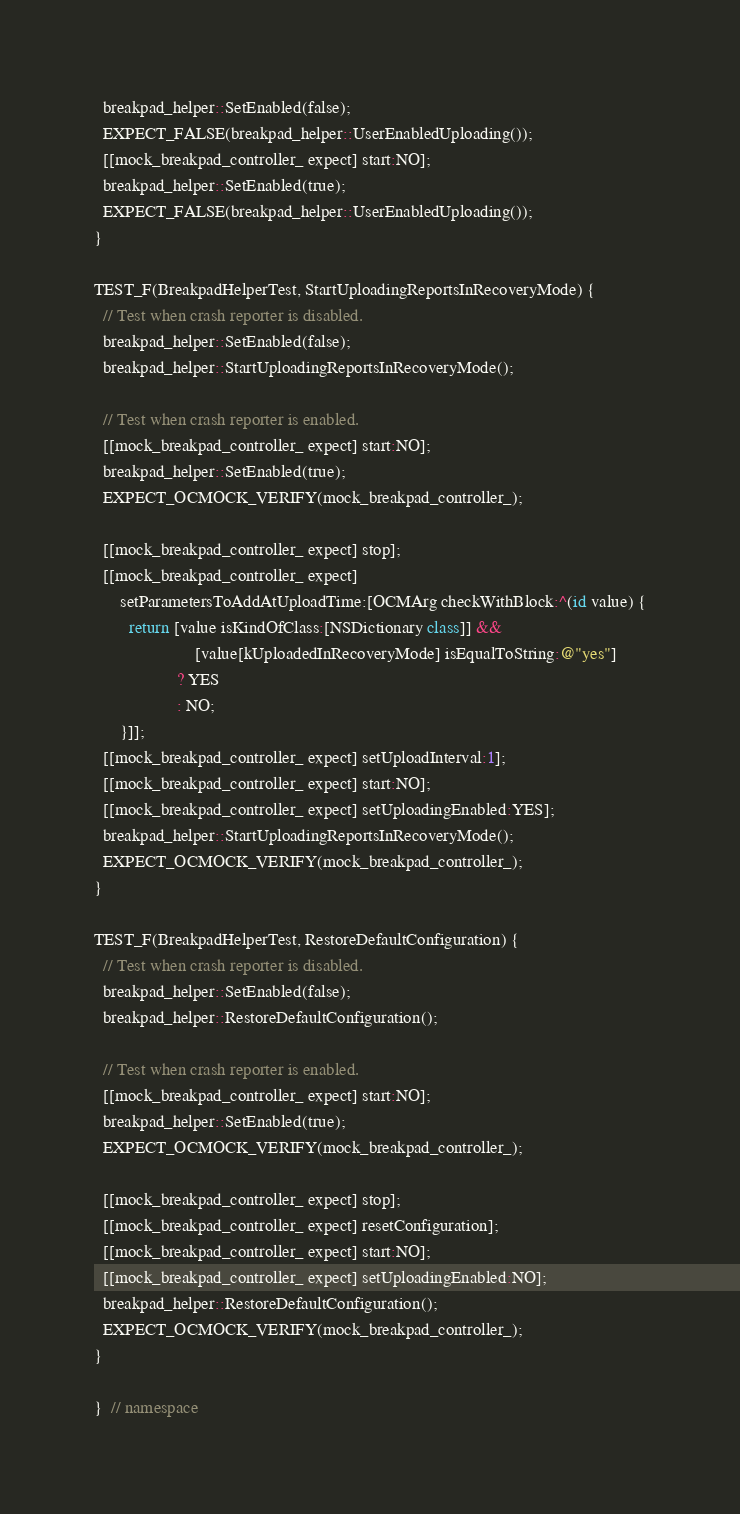Convert code to text. <code><loc_0><loc_0><loc_500><loc_500><_ObjectiveC_>  breakpad_helper::SetEnabled(false);
  EXPECT_FALSE(breakpad_helper::UserEnabledUploading());
  [[mock_breakpad_controller_ expect] start:NO];
  breakpad_helper::SetEnabled(true);
  EXPECT_FALSE(breakpad_helper::UserEnabledUploading());
}

TEST_F(BreakpadHelperTest, StartUploadingReportsInRecoveryMode) {
  // Test when crash reporter is disabled.
  breakpad_helper::SetEnabled(false);
  breakpad_helper::StartUploadingReportsInRecoveryMode();

  // Test when crash reporter is enabled.
  [[mock_breakpad_controller_ expect] start:NO];
  breakpad_helper::SetEnabled(true);
  EXPECT_OCMOCK_VERIFY(mock_breakpad_controller_);

  [[mock_breakpad_controller_ expect] stop];
  [[mock_breakpad_controller_ expect]
      setParametersToAddAtUploadTime:[OCMArg checkWithBlock:^(id value) {
        return [value isKindOfClass:[NSDictionary class]] &&
                       [value[kUploadedInRecoveryMode] isEqualToString:@"yes"]
                   ? YES
                   : NO;
      }]];
  [[mock_breakpad_controller_ expect] setUploadInterval:1];
  [[mock_breakpad_controller_ expect] start:NO];
  [[mock_breakpad_controller_ expect] setUploadingEnabled:YES];
  breakpad_helper::StartUploadingReportsInRecoveryMode();
  EXPECT_OCMOCK_VERIFY(mock_breakpad_controller_);
}

TEST_F(BreakpadHelperTest, RestoreDefaultConfiguration) {
  // Test when crash reporter is disabled.
  breakpad_helper::SetEnabled(false);
  breakpad_helper::RestoreDefaultConfiguration();

  // Test when crash reporter is enabled.
  [[mock_breakpad_controller_ expect] start:NO];
  breakpad_helper::SetEnabled(true);
  EXPECT_OCMOCK_VERIFY(mock_breakpad_controller_);

  [[mock_breakpad_controller_ expect] stop];
  [[mock_breakpad_controller_ expect] resetConfiguration];
  [[mock_breakpad_controller_ expect] start:NO];
  [[mock_breakpad_controller_ expect] setUploadingEnabled:NO];
  breakpad_helper::RestoreDefaultConfiguration();
  EXPECT_OCMOCK_VERIFY(mock_breakpad_controller_);
}

}  // namespace
</code> 